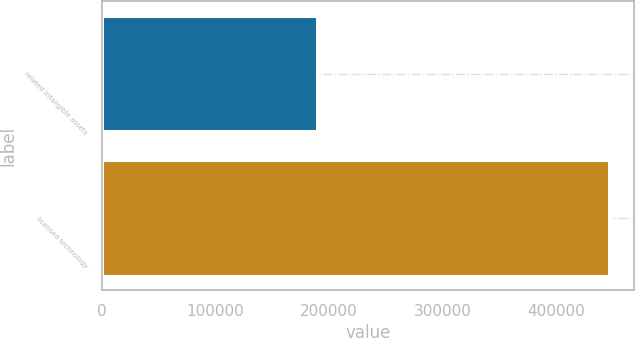<chart> <loc_0><loc_0><loc_500><loc_500><bar_chart><fcel>related intangible assets<fcel>licensed technology<nl><fcel>189239<fcel>446196<nl></chart> 